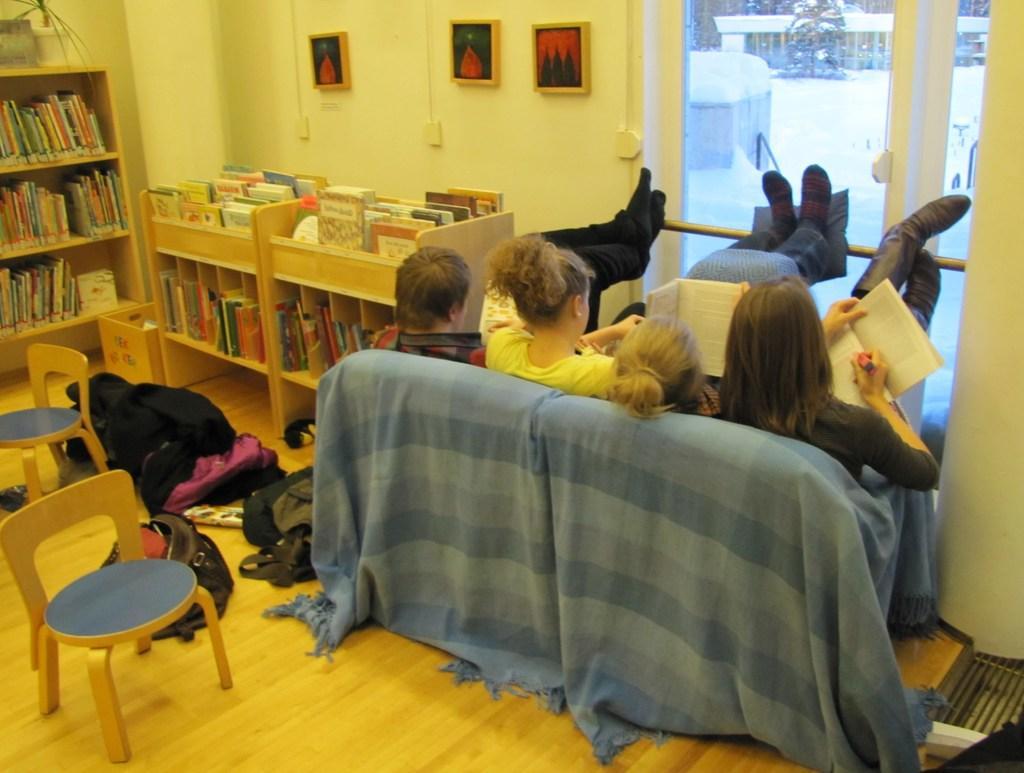Could you give a brief overview of what you see in this image? This is a picture taken in a room, in this room there are a group of people sitting on a sofa the sofa. The sofa is covered with a cloth. On the left to them there is a shelf on the shelf's there are the books and on top of the shelf there is a wall which is in cream color. On the floor there are two chairs and clothes. 